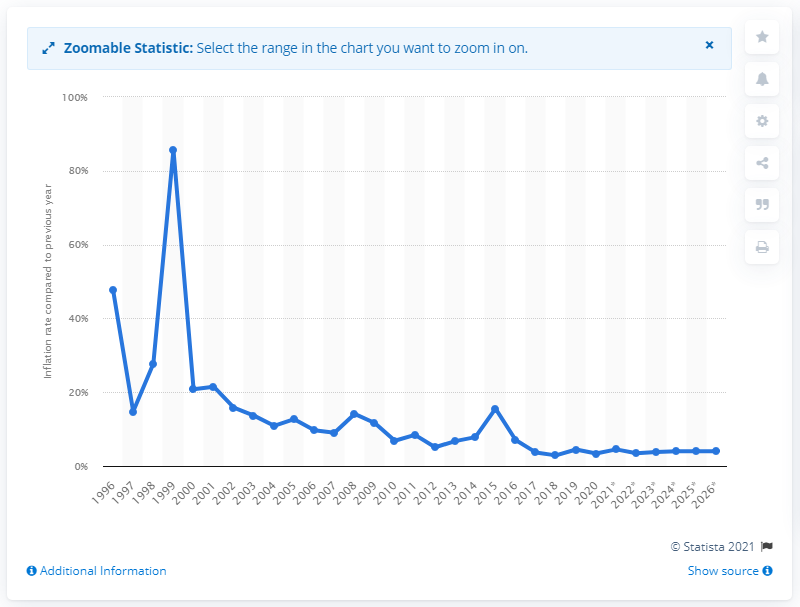Specify some key components in this picture. In 2020, the inflation rate in Russia was 3.38%. 